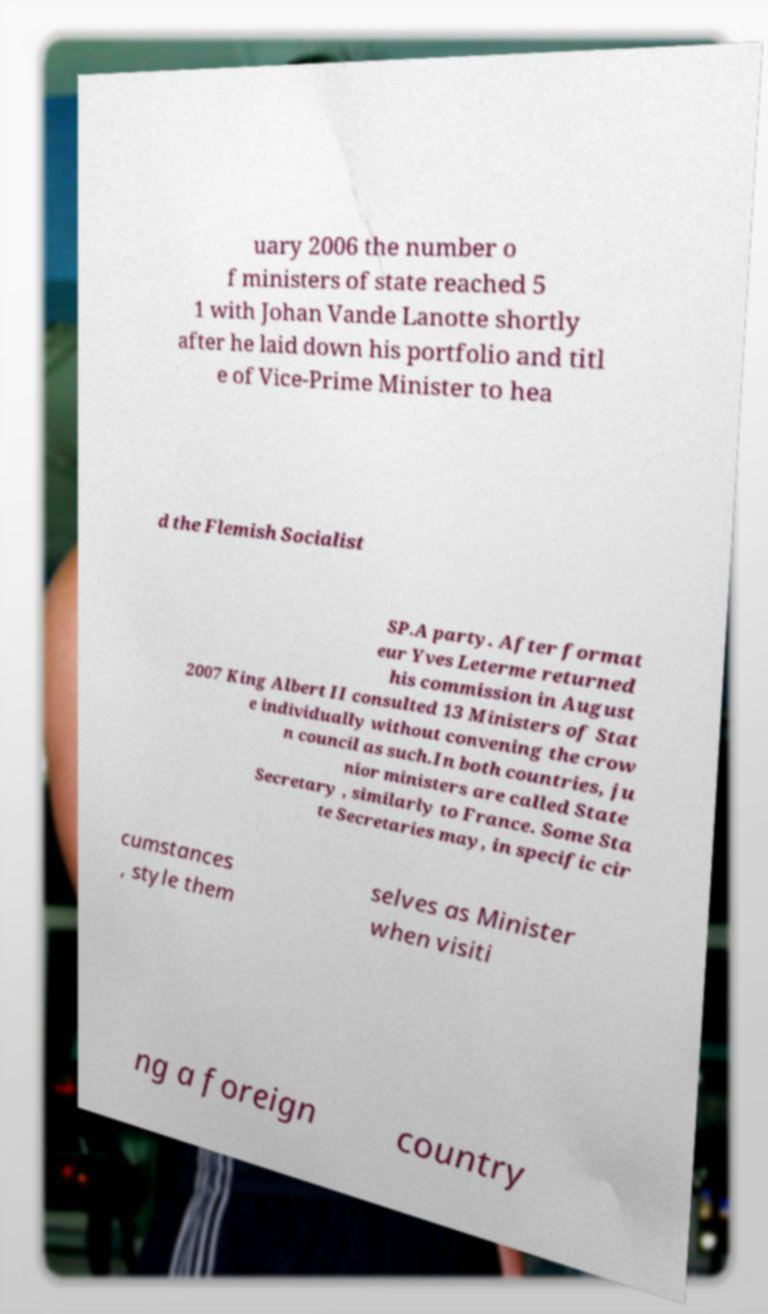Could you assist in decoding the text presented in this image and type it out clearly? uary 2006 the number o f ministers of state reached 5 1 with Johan Vande Lanotte shortly after he laid down his portfolio and titl e of Vice-Prime Minister to hea d the Flemish Socialist SP.A party. After format eur Yves Leterme returned his commission in August 2007 King Albert II consulted 13 Ministers of Stat e individually without convening the crow n council as such.In both countries, ju nior ministers are called State Secretary , similarly to France. Some Sta te Secretaries may, in specific cir cumstances , style them selves as Minister when visiti ng a foreign country 